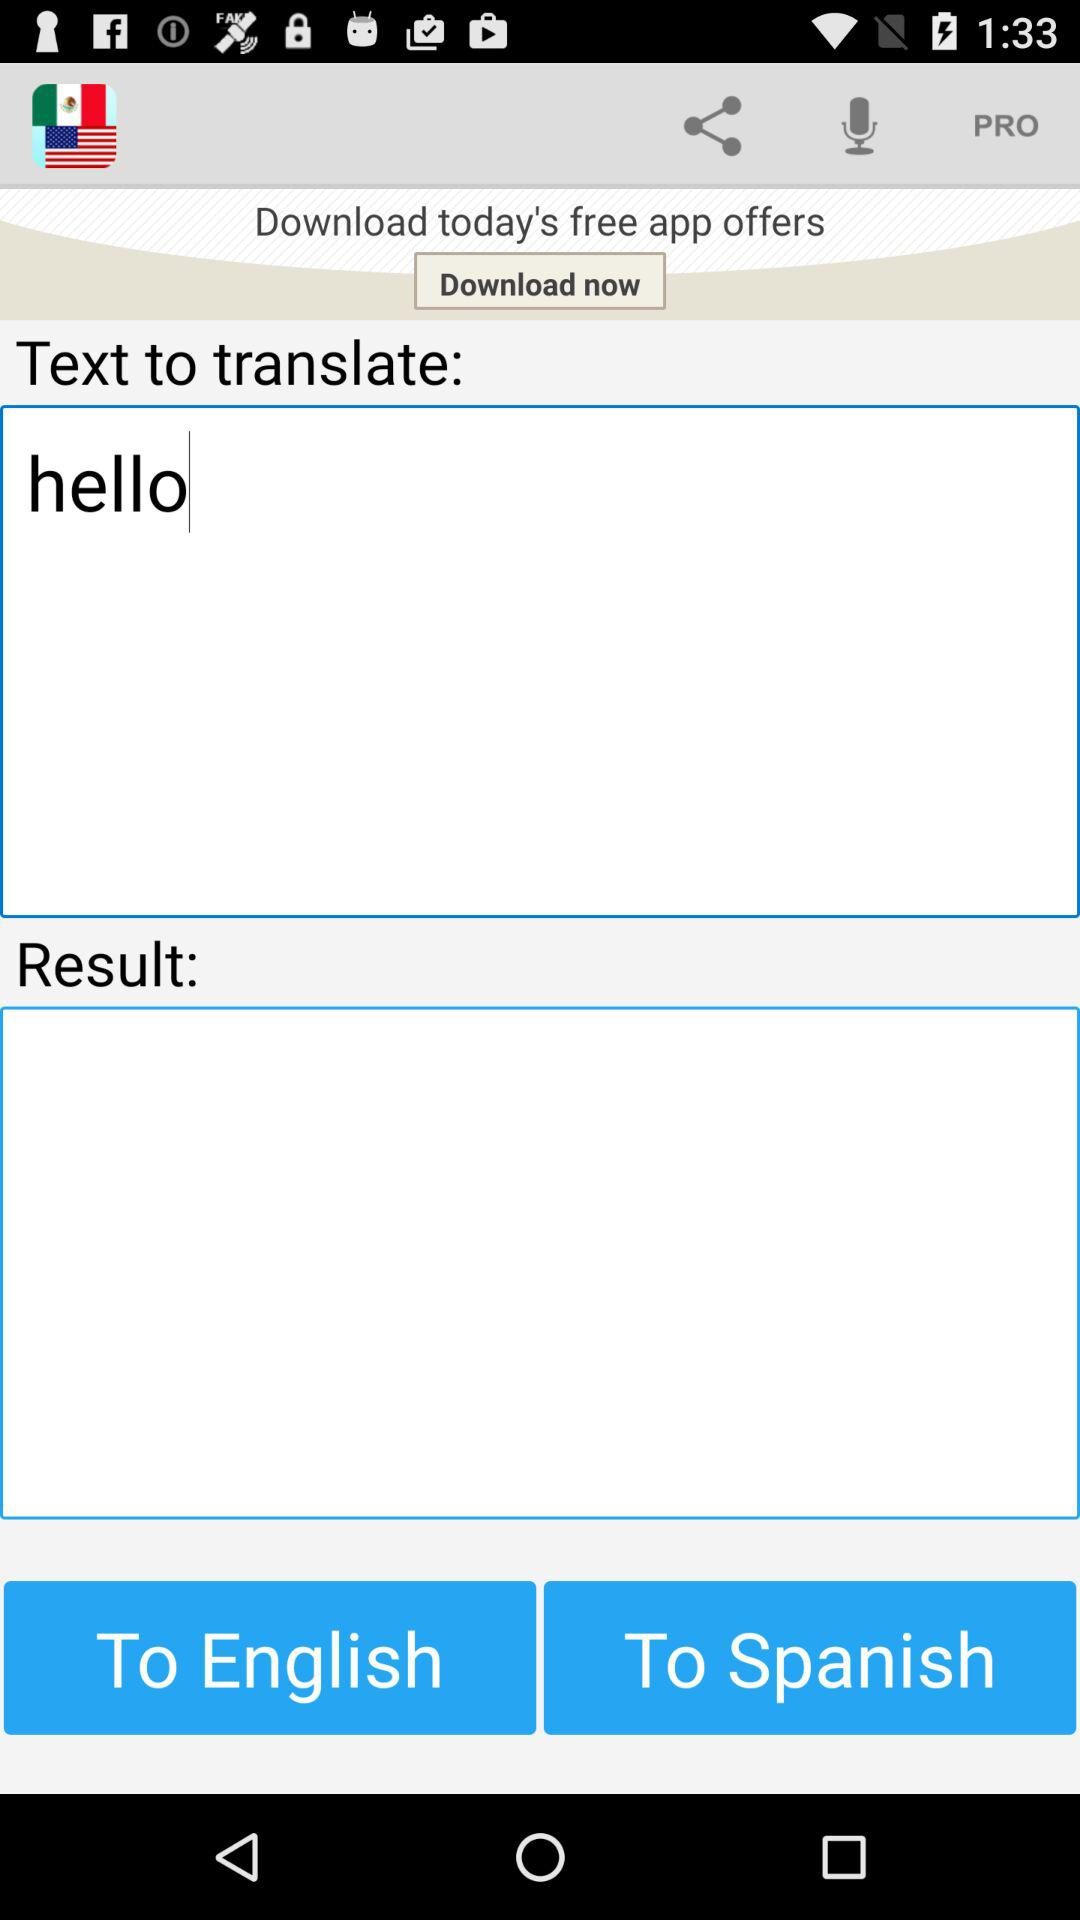Which word is written to translate? The written word to translate is "hello". 